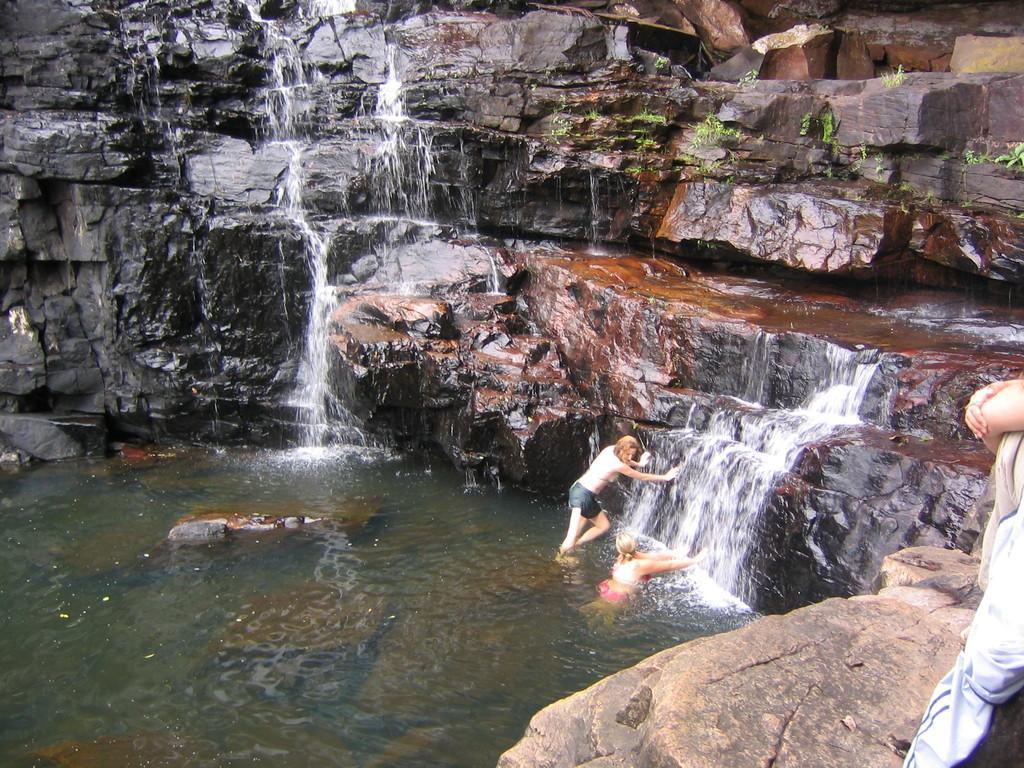In one or two sentences, can you explain what this image depicts? In this image I see the rocks and I see the water and I see 2 women and a person over here. 